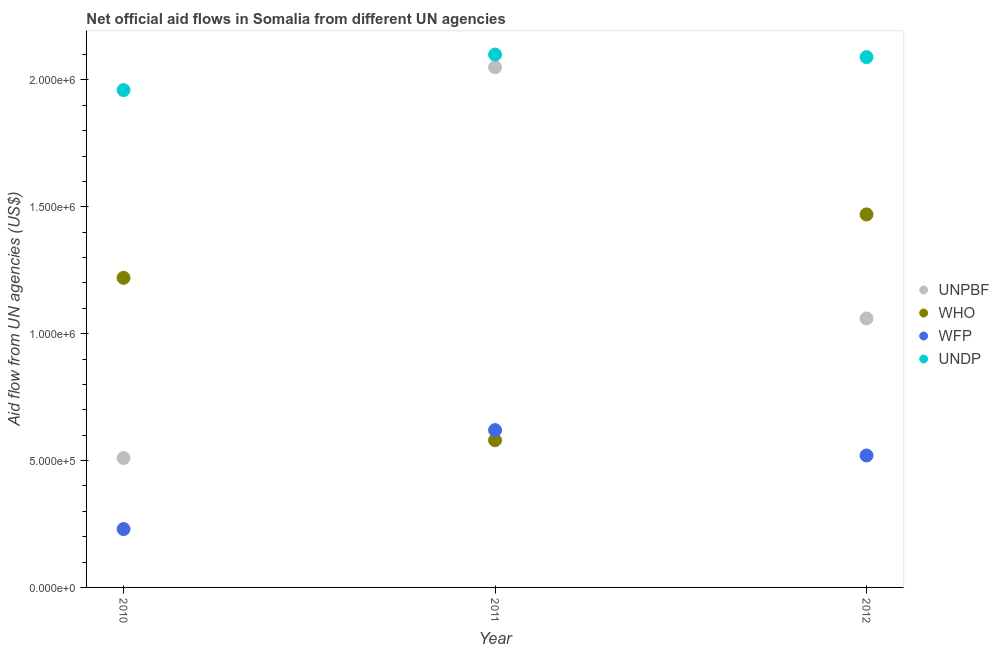How many different coloured dotlines are there?
Your response must be concise. 4. What is the amount of aid given by unpbf in 2011?
Provide a short and direct response. 2.05e+06. Across all years, what is the maximum amount of aid given by undp?
Provide a short and direct response. 2.10e+06. Across all years, what is the minimum amount of aid given by unpbf?
Provide a succinct answer. 5.10e+05. In which year was the amount of aid given by wfp maximum?
Provide a succinct answer. 2011. What is the total amount of aid given by wfp in the graph?
Offer a very short reply. 1.37e+06. What is the difference between the amount of aid given by wfp in 2011 and that in 2012?
Your answer should be compact. 1.00e+05. What is the difference between the amount of aid given by unpbf in 2011 and the amount of aid given by wfp in 2012?
Offer a terse response. 1.53e+06. What is the average amount of aid given by wfp per year?
Give a very brief answer. 4.57e+05. In the year 2010, what is the difference between the amount of aid given by unpbf and amount of aid given by undp?
Make the answer very short. -1.45e+06. In how many years, is the amount of aid given by unpbf greater than 300000 US$?
Your answer should be compact. 3. What is the ratio of the amount of aid given by undp in 2010 to that in 2011?
Provide a short and direct response. 0.93. Is the amount of aid given by who in 2010 less than that in 2011?
Your response must be concise. No. What is the difference between the highest and the second highest amount of aid given by undp?
Provide a short and direct response. 10000. What is the difference between the highest and the lowest amount of aid given by undp?
Provide a succinct answer. 1.40e+05. In how many years, is the amount of aid given by wfp greater than the average amount of aid given by wfp taken over all years?
Your answer should be very brief. 2. Is the sum of the amount of aid given by wfp in 2010 and 2011 greater than the maximum amount of aid given by undp across all years?
Provide a succinct answer. No. Is it the case that in every year, the sum of the amount of aid given by unpbf and amount of aid given by who is greater than the amount of aid given by wfp?
Keep it short and to the point. Yes. Is the amount of aid given by unpbf strictly less than the amount of aid given by wfp over the years?
Your response must be concise. No. How many years are there in the graph?
Your response must be concise. 3. What is the difference between two consecutive major ticks on the Y-axis?
Your response must be concise. 5.00e+05. Does the graph contain any zero values?
Your response must be concise. No. Does the graph contain grids?
Ensure brevity in your answer.  No. Where does the legend appear in the graph?
Provide a succinct answer. Center right. What is the title of the graph?
Your answer should be very brief. Net official aid flows in Somalia from different UN agencies. What is the label or title of the Y-axis?
Give a very brief answer. Aid flow from UN agencies (US$). What is the Aid flow from UN agencies (US$) of UNPBF in 2010?
Keep it short and to the point. 5.10e+05. What is the Aid flow from UN agencies (US$) in WHO in 2010?
Keep it short and to the point. 1.22e+06. What is the Aid flow from UN agencies (US$) of WFP in 2010?
Ensure brevity in your answer.  2.30e+05. What is the Aid flow from UN agencies (US$) of UNDP in 2010?
Make the answer very short. 1.96e+06. What is the Aid flow from UN agencies (US$) of UNPBF in 2011?
Ensure brevity in your answer.  2.05e+06. What is the Aid flow from UN agencies (US$) in WHO in 2011?
Your answer should be compact. 5.80e+05. What is the Aid flow from UN agencies (US$) of WFP in 2011?
Offer a terse response. 6.20e+05. What is the Aid flow from UN agencies (US$) in UNDP in 2011?
Ensure brevity in your answer.  2.10e+06. What is the Aid flow from UN agencies (US$) in UNPBF in 2012?
Offer a very short reply. 1.06e+06. What is the Aid flow from UN agencies (US$) of WHO in 2012?
Make the answer very short. 1.47e+06. What is the Aid flow from UN agencies (US$) of WFP in 2012?
Your response must be concise. 5.20e+05. What is the Aid flow from UN agencies (US$) in UNDP in 2012?
Your answer should be compact. 2.09e+06. Across all years, what is the maximum Aid flow from UN agencies (US$) of UNPBF?
Provide a short and direct response. 2.05e+06. Across all years, what is the maximum Aid flow from UN agencies (US$) of WHO?
Give a very brief answer. 1.47e+06. Across all years, what is the maximum Aid flow from UN agencies (US$) in WFP?
Provide a short and direct response. 6.20e+05. Across all years, what is the maximum Aid flow from UN agencies (US$) in UNDP?
Keep it short and to the point. 2.10e+06. Across all years, what is the minimum Aid flow from UN agencies (US$) of UNPBF?
Ensure brevity in your answer.  5.10e+05. Across all years, what is the minimum Aid flow from UN agencies (US$) of WHO?
Make the answer very short. 5.80e+05. Across all years, what is the minimum Aid flow from UN agencies (US$) in WFP?
Make the answer very short. 2.30e+05. Across all years, what is the minimum Aid flow from UN agencies (US$) in UNDP?
Your answer should be compact. 1.96e+06. What is the total Aid flow from UN agencies (US$) in UNPBF in the graph?
Provide a short and direct response. 3.62e+06. What is the total Aid flow from UN agencies (US$) in WHO in the graph?
Ensure brevity in your answer.  3.27e+06. What is the total Aid flow from UN agencies (US$) in WFP in the graph?
Your response must be concise. 1.37e+06. What is the total Aid flow from UN agencies (US$) in UNDP in the graph?
Offer a very short reply. 6.15e+06. What is the difference between the Aid flow from UN agencies (US$) of UNPBF in 2010 and that in 2011?
Your response must be concise. -1.54e+06. What is the difference between the Aid flow from UN agencies (US$) of WHO in 2010 and that in 2011?
Ensure brevity in your answer.  6.40e+05. What is the difference between the Aid flow from UN agencies (US$) of WFP in 2010 and that in 2011?
Your answer should be compact. -3.90e+05. What is the difference between the Aid flow from UN agencies (US$) in UNPBF in 2010 and that in 2012?
Offer a very short reply. -5.50e+05. What is the difference between the Aid flow from UN agencies (US$) of UNDP in 2010 and that in 2012?
Your response must be concise. -1.30e+05. What is the difference between the Aid flow from UN agencies (US$) of UNPBF in 2011 and that in 2012?
Give a very brief answer. 9.90e+05. What is the difference between the Aid flow from UN agencies (US$) in WHO in 2011 and that in 2012?
Offer a terse response. -8.90e+05. What is the difference between the Aid flow from UN agencies (US$) of WFP in 2011 and that in 2012?
Keep it short and to the point. 1.00e+05. What is the difference between the Aid flow from UN agencies (US$) of UNPBF in 2010 and the Aid flow from UN agencies (US$) of WFP in 2011?
Provide a succinct answer. -1.10e+05. What is the difference between the Aid flow from UN agencies (US$) in UNPBF in 2010 and the Aid flow from UN agencies (US$) in UNDP in 2011?
Your answer should be very brief. -1.59e+06. What is the difference between the Aid flow from UN agencies (US$) in WHO in 2010 and the Aid flow from UN agencies (US$) in WFP in 2011?
Your answer should be very brief. 6.00e+05. What is the difference between the Aid flow from UN agencies (US$) in WHO in 2010 and the Aid flow from UN agencies (US$) in UNDP in 2011?
Your answer should be compact. -8.80e+05. What is the difference between the Aid flow from UN agencies (US$) of WFP in 2010 and the Aid flow from UN agencies (US$) of UNDP in 2011?
Your response must be concise. -1.87e+06. What is the difference between the Aid flow from UN agencies (US$) of UNPBF in 2010 and the Aid flow from UN agencies (US$) of WHO in 2012?
Your response must be concise. -9.60e+05. What is the difference between the Aid flow from UN agencies (US$) of UNPBF in 2010 and the Aid flow from UN agencies (US$) of WFP in 2012?
Offer a very short reply. -10000. What is the difference between the Aid flow from UN agencies (US$) of UNPBF in 2010 and the Aid flow from UN agencies (US$) of UNDP in 2012?
Your answer should be very brief. -1.58e+06. What is the difference between the Aid flow from UN agencies (US$) of WHO in 2010 and the Aid flow from UN agencies (US$) of UNDP in 2012?
Give a very brief answer. -8.70e+05. What is the difference between the Aid flow from UN agencies (US$) of WFP in 2010 and the Aid flow from UN agencies (US$) of UNDP in 2012?
Your answer should be very brief. -1.86e+06. What is the difference between the Aid flow from UN agencies (US$) in UNPBF in 2011 and the Aid flow from UN agencies (US$) in WHO in 2012?
Your answer should be very brief. 5.80e+05. What is the difference between the Aid flow from UN agencies (US$) in UNPBF in 2011 and the Aid flow from UN agencies (US$) in WFP in 2012?
Provide a short and direct response. 1.53e+06. What is the difference between the Aid flow from UN agencies (US$) of WHO in 2011 and the Aid flow from UN agencies (US$) of WFP in 2012?
Your answer should be compact. 6.00e+04. What is the difference between the Aid flow from UN agencies (US$) in WHO in 2011 and the Aid flow from UN agencies (US$) in UNDP in 2012?
Offer a terse response. -1.51e+06. What is the difference between the Aid flow from UN agencies (US$) of WFP in 2011 and the Aid flow from UN agencies (US$) of UNDP in 2012?
Your answer should be very brief. -1.47e+06. What is the average Aid flow from UN agencies (US$) of UNPBF per year?
Provide a succinct answer. 1.21e+06. What is the average Aid flow from UN agencies (US$) of WHO per year?
Keep it short and to the point. 1.09e+06. What is the average Aid flow from UN agencies (US$) of WFP per year?
Your response must be concise. 4.57e+05. What is the average Aid flow from UN agencies (US$) of UNDP per year?
Provide a short and direct response. 2.05e+06. In the year 2010, what is the difference between the Aid flow from UN agencies (US$) in UNPBF and Aid flow from UN agencies (US$) in WHO?
Your answer should be compact. -7.10e+05. In the year 2010, what is the difference between the Aid flow from UN agencies (US$) of UNPBF and Aid flow from UN agencies (US$) of UNDP?
Ensure brevity in your answer.  -1.45e+06. In the year 2010, what is the difference between the Aid flow from UN agencies (US$) of WHO and Aid flow from UN agencies (US$) of WFP?
Ensure brevity in your answer.  9.90e+05. In the year 2010, what is the difference between the Aid flow from UN agencies (US$) of WHO and Aid flow from UN agencies (US$) of UNDP?
Keep it short and to the point. -7.40e+05. In the year 2010, what is the difference between the Aid flow from UN agencies (US$) in WFP and Aid flow from UN agencies (US$) in UNDP?
Your response must be concise. -1.73e+06. In the year 2011, what is the difference between the Aid flow from UN agencies (US$) in UNPBF and Aid flow from UN agencies (US$) in WHO?
Provide a short and direct response. 1.47e+06. In the year 2011, what is the difference between the Aid flow from UN agencies (US$) of UNPBF and Aid flow from UN agencies (US$) of WFP?
Ensure brevity in your answer.  1.43e+06. In the year 2011, what is the difference between the Aid flow from UN agencies (US$) of WHO and Aid flow from UN agencies (US$) of UNDP?
Your answer should be compact. -1.52e+06. In the year 2011, what is the difference between the Aid flow from UN agencies (US$) in WFP and Aid flow from UN agencies (US$) in UNDP?
Provide a succinct answer. -1.48e+06. In the year 2012, what is the difference between the Aid flow from UN agencies (US$) in UNPBF and Aid flow from UN agencies (US$) in WHO?
Offer a very short reply. -4.10e+05. In the year 2012, what is the difference between the Aid flow from UN agencies (US$) of UNPBF and Aid flow from UN agencies (US$) of WFP?
Your answer should be compact. 5.40e+05. In the year 2012, what is the difference between the Aid flow from UN agencies (US$) of UNPBF and Aid flow from UN agencies (US$) of UNDP?
Keep it short and to the point. -1.03e+06. In the year 2012, what is the difference between the Aid flow from UN agencies (US$) of WHO and Aid flow from UN agencies (US$) of WFP?
Keep it short and to the point. 9.50e+05. In the year 2012, what is the difference between the Aid flow from UN agencies (US$) of WHO and Aid flow from UN agencies (US$) of UNDP?
Give a very brief answer. -6.20e+05. In the year 2012, what is the difference between the Aid flow from UN agencies (US$) of WFP and Aid flow from UN agencies (US$) of UNDP?
Ensure brevity in your answer.  -1.57e+06. What is the ratio of the Aid flow from UN agencies (US$) of UNPBF in 2010 to that in 2011?
Keep it short and to the point. 0.25. What is the ratio of the Aid flow from UN agencies (US$) in WHO in 2010 to that in 2011?
Keep it short and to the point. 2.1. What is the ratio of the Aid flow from UN agencies (US$) of WFP in 2010 to that in 2011?
Give a very brief answer. 0.37. What is the ratio of the Aid flow from UN agencies (US$) of UNPBF in 2010 to that in 2012?
Provide a short and direct response. 0.48. What is the ratio of the Aid flow from UN agencies (US$) in WHO in 2010 to that in 2012?
Your response must be concise. 0.83. What is the ratio of the Aid flow from UN agencies (US$) of WFP in 2010 to that in 2012?
Make the answer very short. 0.44. What is the ratio of the Aid flow from UN agencies (US$) in UNDP in 2010 to that in 2012?
Offer a terse response. 0.94. What is the ratio of the Aid flow from UN agencies (US$) of UNPBF in 2011 to that in 2012?
Keep it short and to the point. 1.93. What is the ratio of the Aid flow from UN agencies (US$) in WHO in 2011 to that in 2012?
Your response must be concise. 0.39. What is the ratio of the Aid flow from UN agencies (US$) in WFP in 2011 to that in 2012?
Make the answer very short. 1.19. What is the difference between the highest and the second highest Aid flow from UN agencies (US$) in UNPBF?
Your answer should be very brief. 9.90e+05. What is the difference between the highest and the second highest Aid flow from UN agencies (US$) in WFP?
Keep it short and to the point. 1.00e+05. What is the difference between the highest and the second highest Aid flow from UN agencies (US$) in UNDP?
Ensure brevity in your answer.  10000. What is the difference between the highest and the lowest Aid flow from UN agencies (US$) in UNPBF?
Give a very brief answer. 1.54e+06. What is the difference between the highest and the lowest Aid flow from UN agencies (US$) of WHO?
Ensure brevity in your answer.  8.90e+05. What is the difference between the highest and the lowest Aid flow from UN agencies (US$) in WFP?
Give a very brief answer. 3.90e+05. What is the difference between the highest and the lowest Aid flow from UN agencies (US$) in UNDP?
Give a very brief answer. 1.40e+05. 